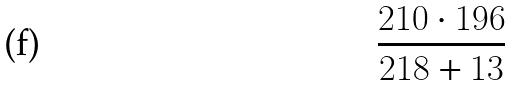<formula> <loc_0><loc_0><loc_500><loc_500>\frac { 2 1 0 \cdot 1 9 6 } { 2 1 8 + 1 3 }</formula> 